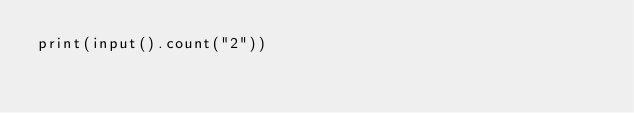<code> <loc_0><loc_0><loc_500><loc_500><_Python_>print(input().count("2"))</code> 